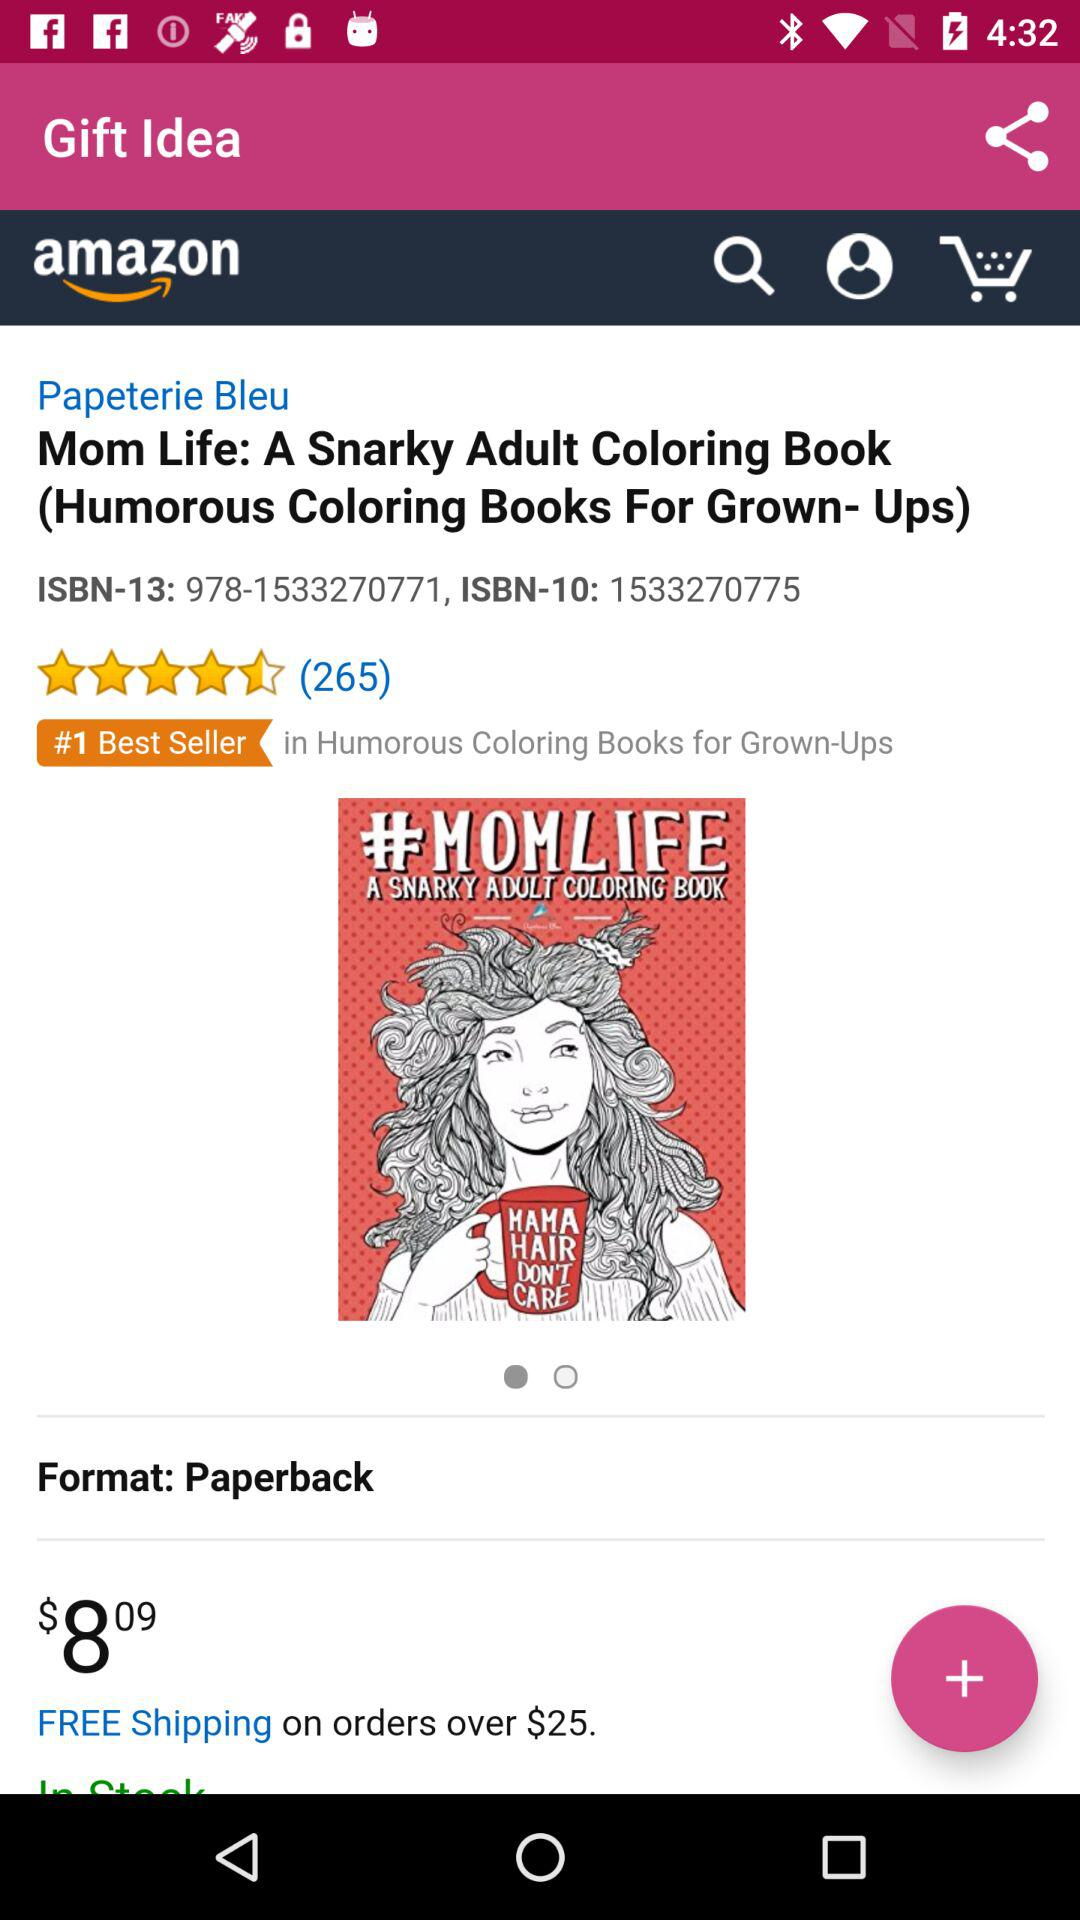What is the ISBN-13 number? The ISBN-13 number is 978-1533270771. 